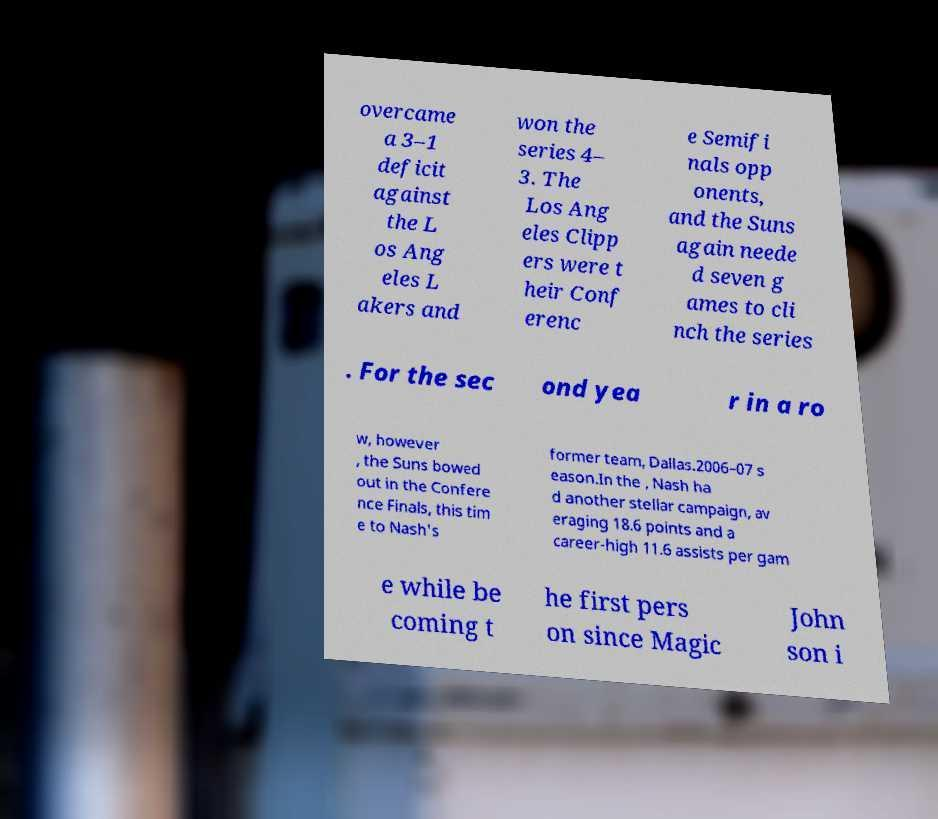Please identify and transcribe the text found in this image. overcame a 3–1 deficit against the L os Ang eles L akers and won the series 4– 3. The Los Ang eles Clipp ers were t heir Conf erenc e Semifi nals opp onents, and the Suns again neede d seven g ames to cli nch the series . For the sec ond yea r in a ro w, however , the Suns bowed out in the Confere nce Finals, this tim e to Nash's former team, Dallas.2006–07 s eason.In the , Nash ha d another stellar campaign, av eraging 18.6 points and a career-high 11.6 assists per gam e while be coming t he first pers on since Magic John son i 